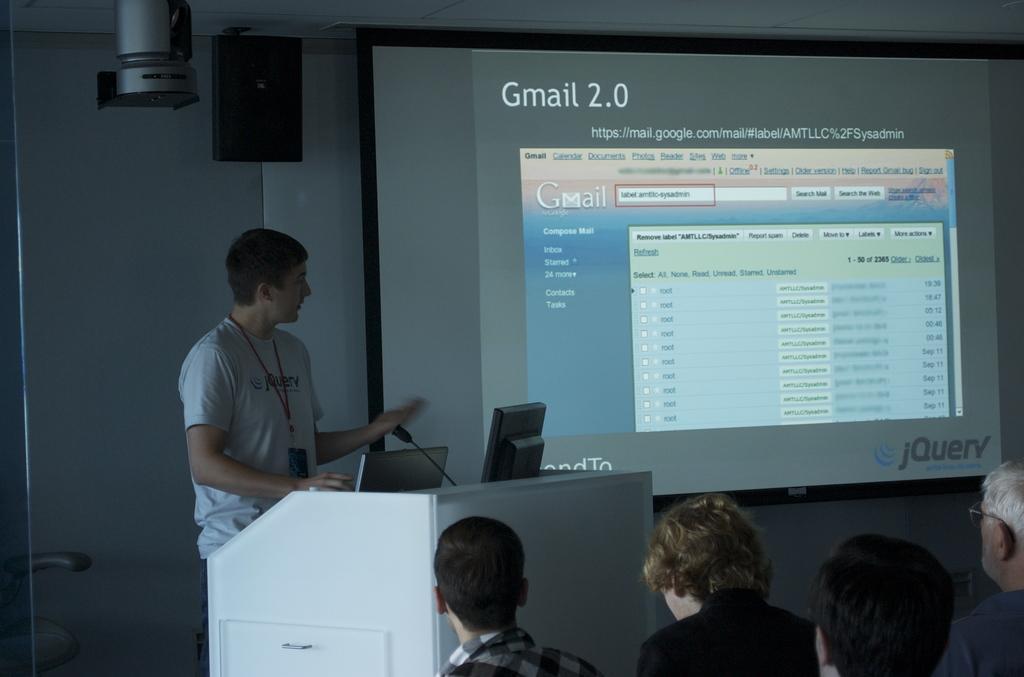In one or two sentences, can you explain what this image depicts? In this image in front there are people. In front of them there is a person standing in front of the dais. On top of the days there are laptops. There is a mike. In the background of the image there is a screen. There is a wall. There is a speaker. Beside the speaker there is some object. 